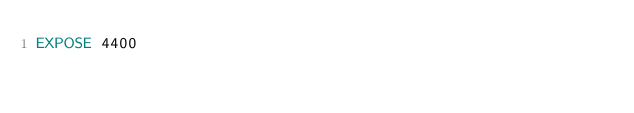<code> <loc_0><loc_0><loc_500><loc_500><_Dockerfile_>EXPOSE 4400
</code> 